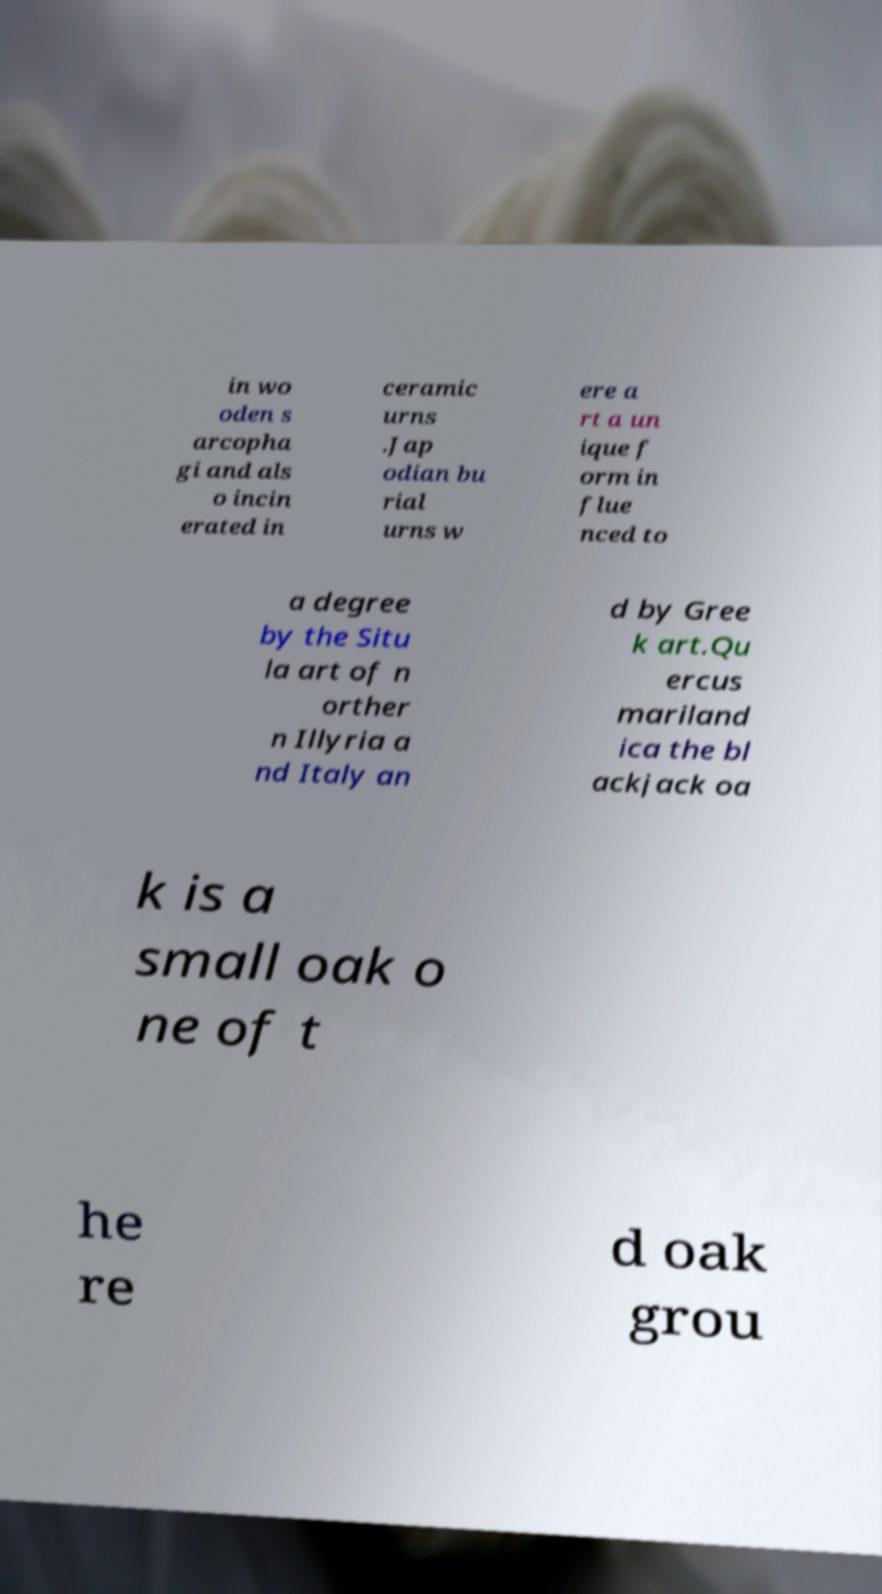For documentation purposes, I need the text within this image transcribed. Could you provide that? in wo oden s arcopha gi and als o incin erated in ceramic urns .Jap odian bu rial urns w ere a rt a un ique f orm in flue nced to a degree by the Situ la art of n orther n Illyria a nd Italy an d by Gree k art.Qu ercus mariland ica the bl ackjack oa k is a small oak o ne of t he re d oak grou 